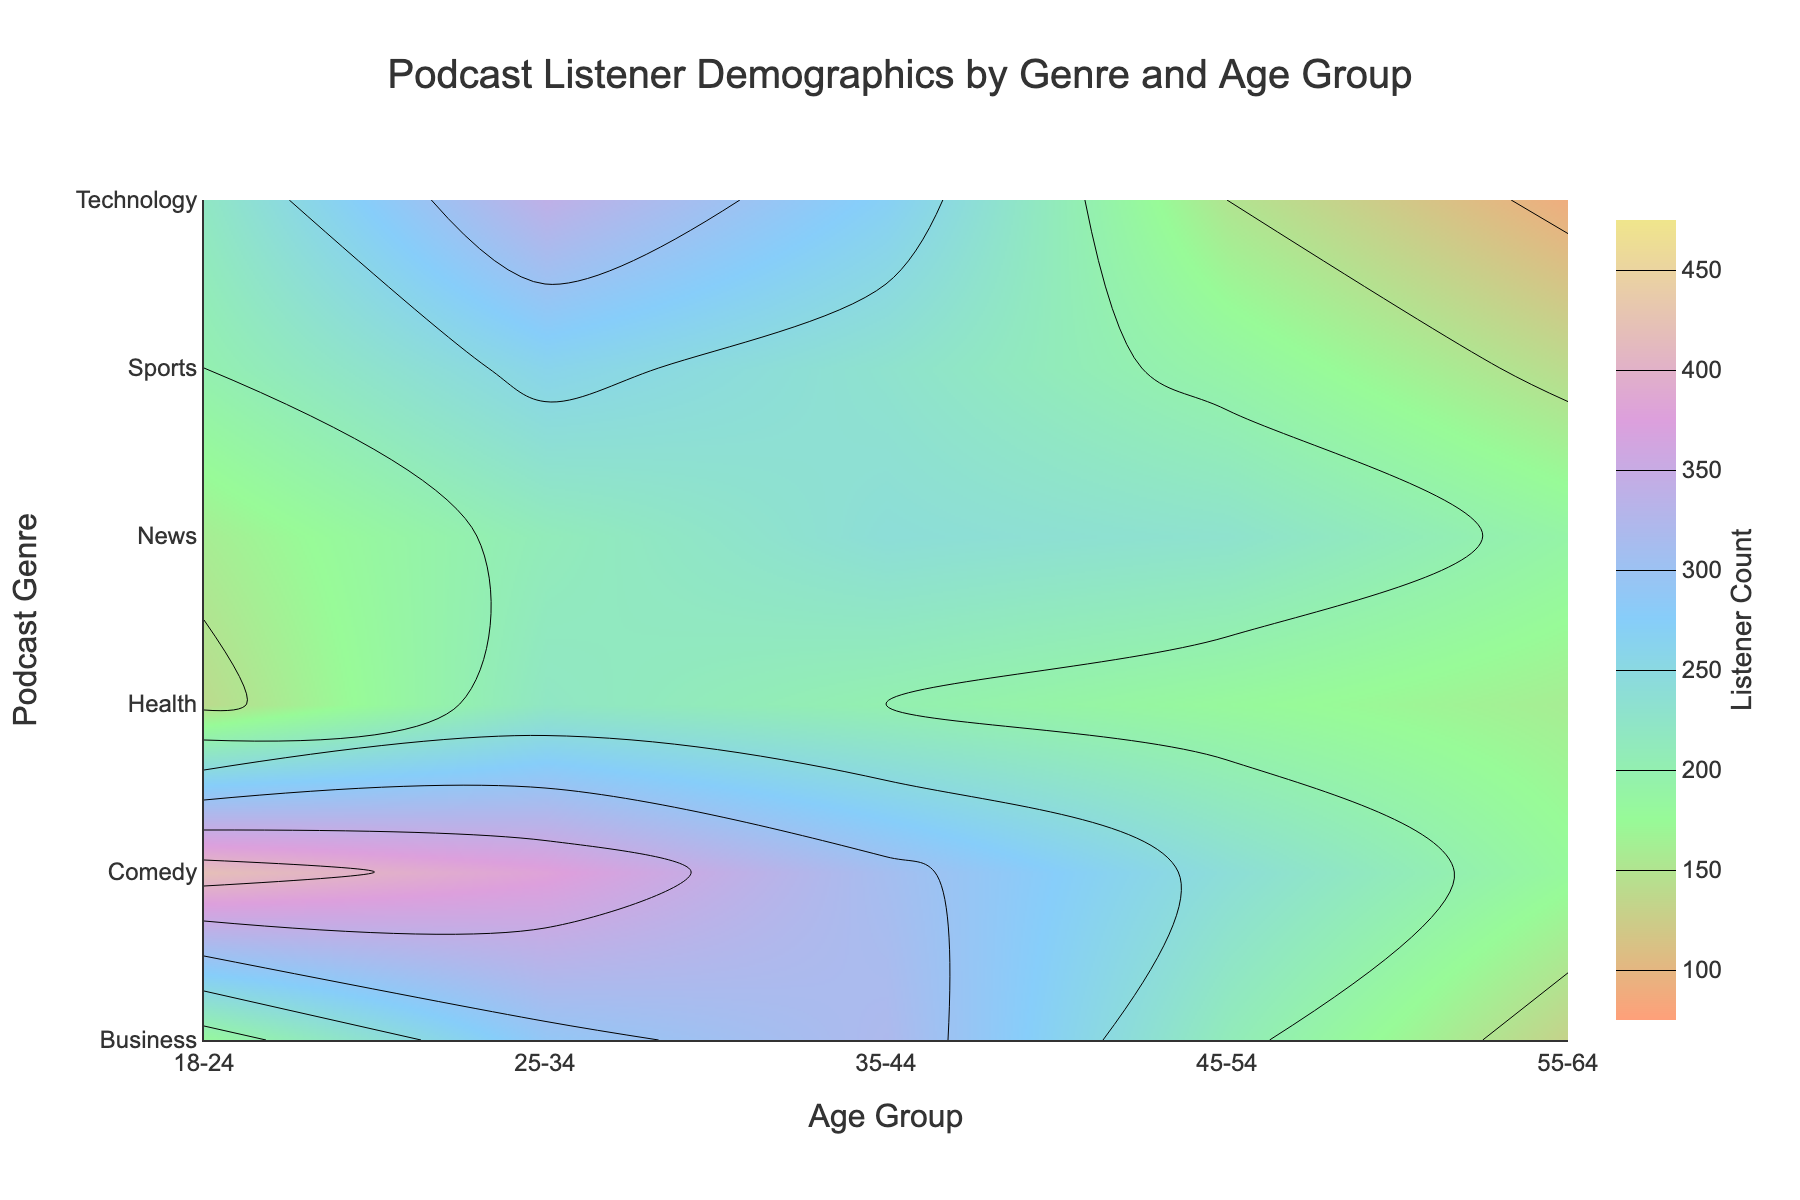What is the title of the figure? The title of the figure is located at the top and is centrally aligned. It reads "Podcast Listener Demographics by Genre and Age Group."
Answer: Podcast Listener Demographics by Genre and Age Group What are the labels of the x-axis and y-axis? The x-axis is labeled "Age Group", and the y-axis is labeled "Podcast Genre". This information is located at the bottom and left sides of the plot, respectively.
Answer: Age Group, Podcast Genre Which age group has the highest listener count in the Comedy genre? The contour plot indicates the number of listeners for each genre across different age groups. For the Comedy genre, the highest listener count is for the 18-24 age group with a count of 420.
Answer: 18-24 What is the range of listener counts represented in the contour plot? The color bar on the right side of the plot indicates the range of listener counts. It starts at 100 and ends at 450.
Answer: 100-450 How does the listener count of the 25-34 age group in the Technology genre compare to that in the News genre? To compare, look at the contour levels for the 25-34 age group in both genres. The Technology genre has a listener count of 340, while the News genre has a count of 210. 340 is greater than 210.
Answer: Technology > News What is the combined listener count for the Health genre across all age groups? Sum the listener counts for all the age groups in the Health genre: 140 (18-24) + 220 (25-34) + 200 (35-44) + 180 (45-54) + 160 (55-64) = 900.
Answer: 900 Which podcast genre has the lowest listener count in the 55-64 age group and what is the count? Review the listener counts for the 55-64 age group across all genres. The Technology genre has the lowest listener count with 90 listeners.
Answer: Technology, 90 What is the average listener count for the Business genre across all age groups? Compute the average by summing the counts for each age group in the Business genre and dividing by the number of age groups: (180 + 290 + 320 + 210 + 130) / 5 = 1130 / 5 = 226.
Answer: 226 Identify the genre with the most consistent listener count across age groups. Inspect the variations in contour levels across age groups for each genre. The Health genre has the most consistent listener counts, ranging from 140 to 220. The variance between these counts is 80, which is relatively low compared to other genres.
Answer: Health 